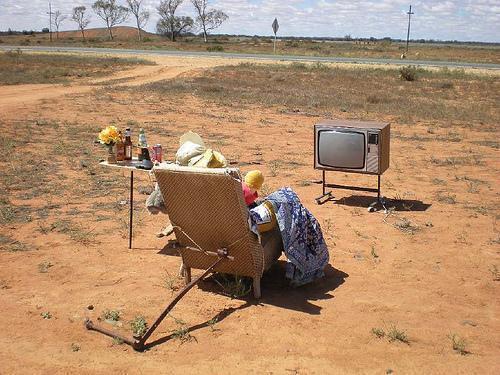Why can't they watch the television?
Choose the correct response, then elucidate: 'Answer: answer
Rationale: rationale.'
Options: No electricity, old television, broken television, solar glare. Answer: no electricity.
Rationale: These appliances run on electricity. What's connected to the back of the chair?
Choose the right answer from the provided options to respond to the question.
Options: Blanket, metal rod, ribbon, tv. Metal rod. 